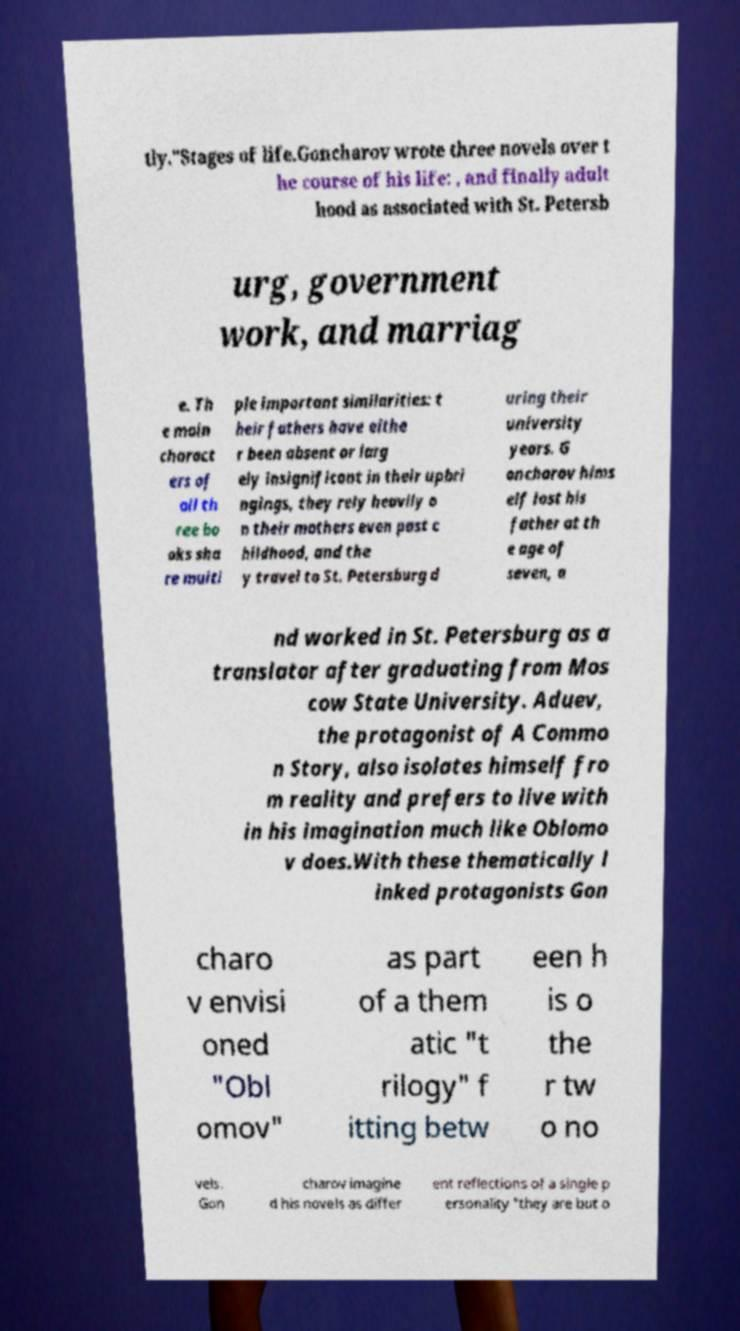Please read and relay the text visible in this image. What does it say? tly."Stages of life.Goncharov wrote three novels over t he course of his life: , and finally adult hood as associated with St. Petersb urg, government work, and marriag e. Th e main charact ers of all th ree bo oks sha re multi ple important similarities: t heir fathers have eithe r been absent or larg ely insignificant in their upbri ngings, they rely heavily o n their mothers even past c hildhood, and the y travel to St. Petersburg d uring their university years. G oncharov hims elf lost his father at th e age of seven, a nd worked in St. Petersburg as a translator after graduating from Mos cow State University. Aduev, the protagonist of A Commo n Story, also isolates himself fro m reality and prefers to live with in his imagination much like Oblomo v does.With these thematically l inked protagonists Gon charo v envisi oned "Obl omov" as part of a them atic "t rilogy" f itting betw een h is o the r tw o no vels. Gon charov imagine d his novels as differ ent reflections of a single p ersonality "they are but o 